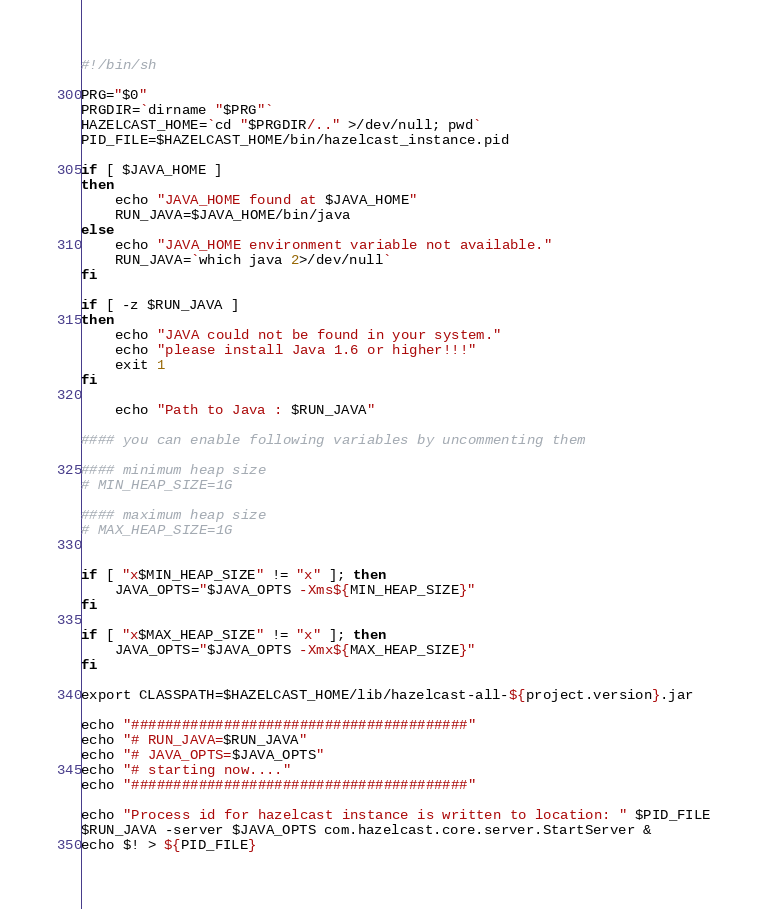<code> <loc_0><loc_0><loc_500><loc_500><_Bash_>#!/bin/sh

PRG="$0"
PRGDIR=`dirname "$PRG"`
HAZELCAST_HOME=`cd "$PRGDIR/.." >/dev/null; pwd`
PID_FILE=$HAZELCAST_HOME/bin/hazelcast_instance.pid

if [ $JAVA_HOME ]
then
	echo "JAVA_HOME found at $JAVA_HOME"
	RUN_JAVA=$JAVA_HOME/bin/java
else
	echo "JAVA_HOME environment variable not available."
    RUN_JAVA=`which java 2>/dev/null`
fi

if [ -z $RUN_JAVA ]
then
    echo "JAVA could not be found in your system."
    echo "please install Java 1.6 or higher!!!"
    exit 1
fi

	echo "Path to Java : $RUN_JAVA"

#### you can enable following variables by uncommenting them

#### minimum heap size
# MIN_HEAP_SIZE=1G

#### maximum heap size
# MAX_HEAP_SIZE=1G


if [ "x$MIN_HEAP_SIZE" != "x" ]; then
	JAVA_OPTS="$JAVA_OPTS -Xms${MIN_HEAP_SIZE}"
fi

if [ "x$MAX_HEAP_SIZE" != "x" ]; then
	JAVA_OPTS="$JAVA_OPTS -Xmx${MAX_HEAP_SIZE}"
fi

export CLASSPATH=$HAZELCAST_HOME/lib/hazelcast-all-${project.version}.jar

echo "########################################"
echo "# RUN_JAVA=$RUN_JAVA"
echo "# JAVA_OPTS=$JAVA_OPTS"
echo "# starting now...."
echo "########################################"

echo "Process id for hazelcast instance is written to location: " $PID_FILE
$RUN_JAVA -server $JAVA_OPTS com.hazelcast.core.server.StartServer &
echo $! > ${PID_FILE}
</code> 